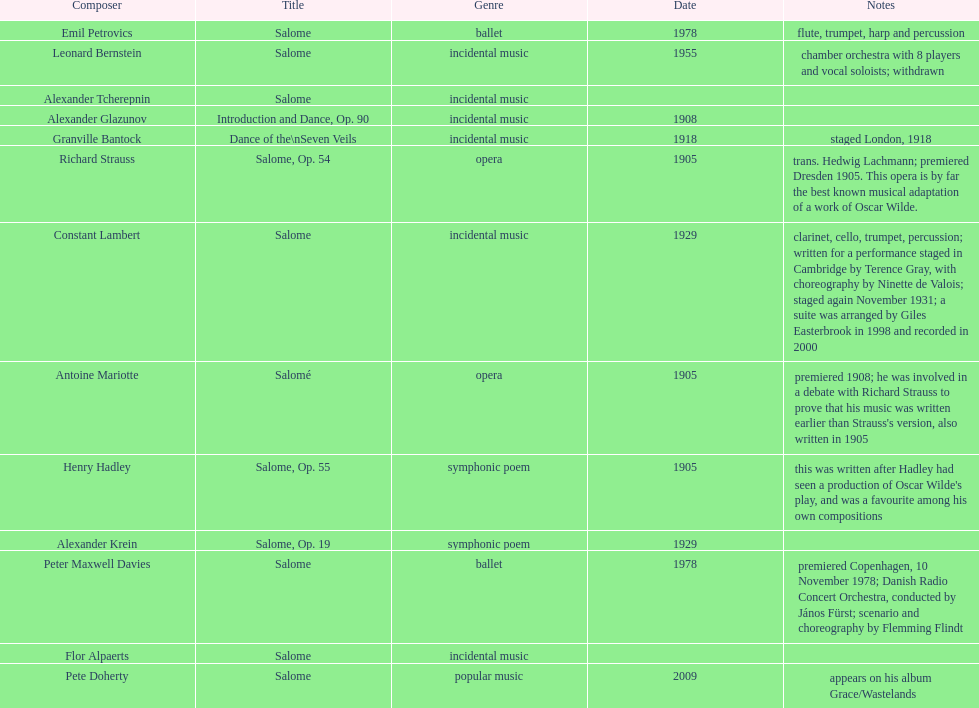Who is on top of the list? Flor Alpaerts. 